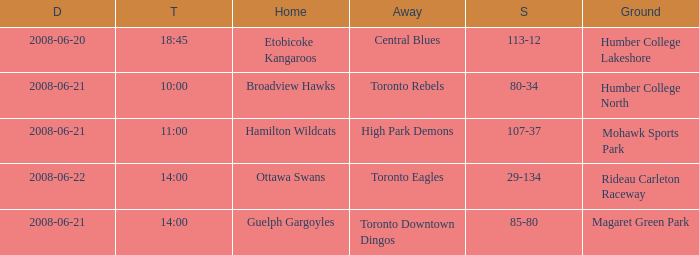What is the Time with a Score that is 80-34? 10:00. 